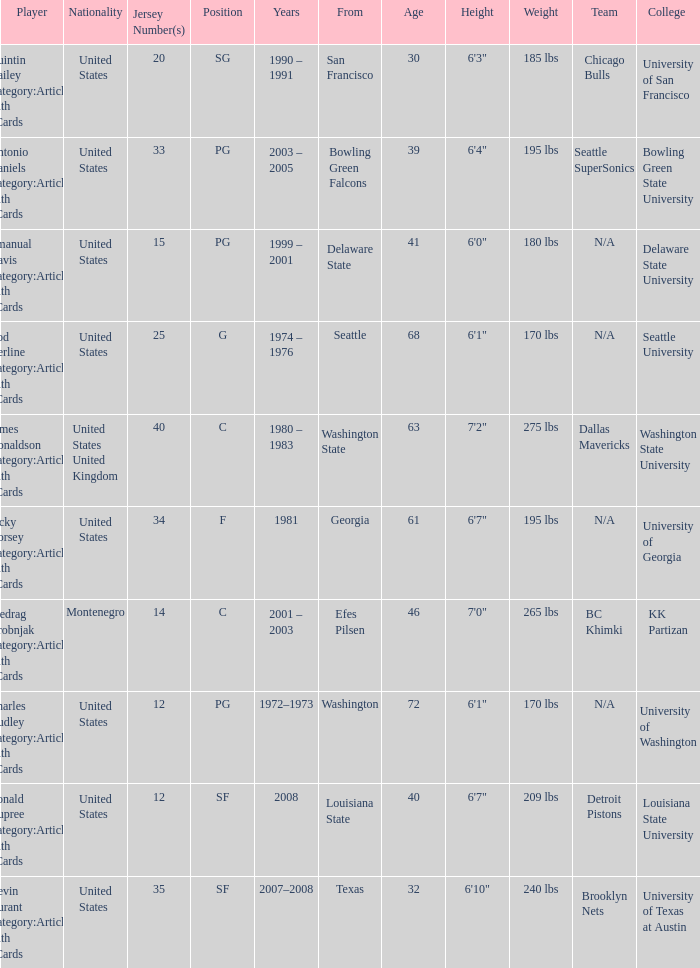What is the lowest jersey number of a player from louisiana state? 12.0. Give me the full table as a dictionary. {'header': ['Player', 'Nationality', 'Jersey Number(s)', 'Position', 'Years', 'From', 'Age', 'Height', 'Weight', 'Team', 'College '], 'rows': [['Quintin Dailey Category:Articles with hCards', 'United States', '20', 'SG', '1990 – 1991', 'San Francisco', '30', '6\'3"', '185 lbs', 'Chicago Bulls', 'University of San Francisco'], ['Antonio Daniels Category:Articles with hCards', 'United States', '33', 'PG', '2003 – 2005', 'Bowling Green Falcons', '39', '6\'4"', '195 lbs', 'Seattle SuperSonics', 'Bowling Green State University'], ['Emanual Davis Category:Articles with hCards', 'United States', '15', 'PG', '1999 – 2001', 'Delaware State', '41', '6\'0"', '180 lbs', 'N/A', 'Delaware State University'], ['Rod Derline Category:Articles with hCards', 'United States', '25', 'G', '1974 – 1976', 'Seattle', '68', '6\'1"', '170 lbs', 'N/A', 'Seattle University'], ['James Donaldson Category:Articles with hCards', 'United States United Kingdom', '40', 'C', '1980 – 1983', 'Washington State', '63', '7\'2"', '275 lbs', 'Dallas Mavericks', 'Washington State University'], ['Jacky Dorsey Category:Articles with hCards', 'United States', '34', 'F', '1981', 'Georgia', '61', '6\'7"', '195 lbs', 'N/A', 'University of Georgia'], ['Predrag Drobnjak Category:Articles with hCards', 'Montenegro', '14', 'C', '2001 – 2003', 'Efes Pilsen', '46', '7\'0"', '265 lbs', 'BC Khimki', 'KK Partizan'], ['Charles Dudley Category:Articles with hCards', 'United States', '12', 'PG', '1972–1973', 'Washington', '72', '6\'1"', '170 lbs', 'N/A', 'University of Washington'], ['Ronald Dupree Category:Articles with hCards', 'United States', '12', 'SF', '2008', 'Louisiana State', '40', '6\'7"', '209 lbs', 'Detroit Pistons', 'Louisiana State University'], ['Kevin Durant Category:Articles with hCards', 'United States', '35', 'SF', '2007–2008', 'Texas', '32', '6\'10"', '240 lbs', 'Brooklyn Nets', 'University of Texas at Austin']]} 